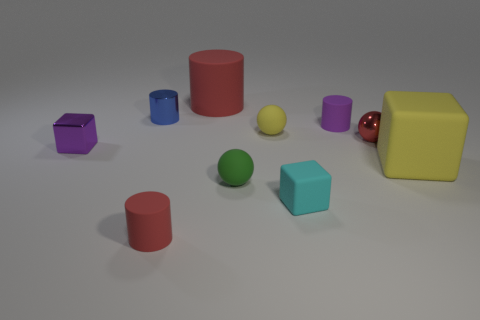Subtract all green cubes. How many red cylinders are left? 2 Subtract all large cubes. How many cubes are left? 2 Subtract 1 cubes. How many cubes are left? 2 Subtract all purple cylinders. How many cylinders are left? 3 Subtract all green cylinders. Subtract all gray cubes. How many cylinders are left? 4 Subtract all blocks. How many objects are left? 7 Add 1 large yellow matte things. How many large yellow matte things are left? 2 Add 1 big red things. How many big red things exist? 2 Subtract 0 purple balls. How many objects are left? 10 Subtract all big yellow matte blocks. Subtract all large yellow matte objects. How many objects are left? 8 